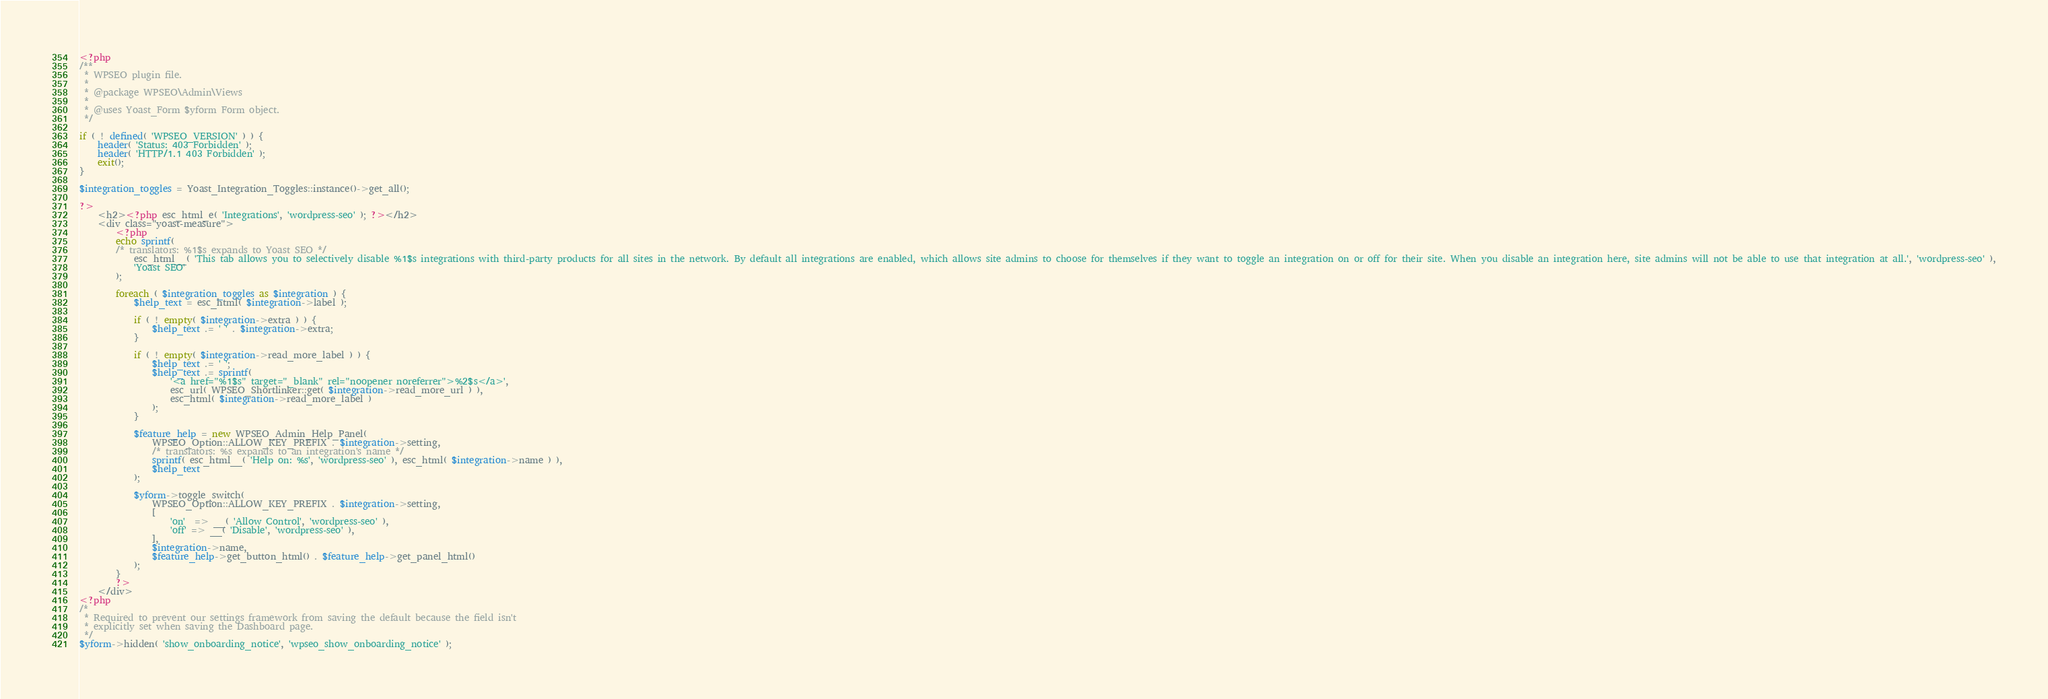<code> <loc_0><loc_0><loc_500><loc_500><_PHP_><?php
/**
 * WPSEO plugin file.
 *
 * @package WPSEO\Admin\Views
 *
 * @uses Yoast_Form $yform Form object.
 */

if ( ! defined( 'WPSEO_VERSION' ) ) {
	header( 'Status: 403 Forbidden' );
	header( 'HTTP/1.1 403 Forbidden' );
	exit();
}

$integration_toggles = Yoast_Integration_Toggles::instance()->get_all();

?>
	<h2><?php esc_html_e( 'Integrations', 'wordpress-seo' ); ?></h2>
	<div class="yoast-measure">
		<?php
		echo sprintf(
		/* translators: %1$s expands to Yoast SEO */
			esc_html__( 'This tab allows you to selectively disable %1$s integrations with third-party products for all sites in the network. By default all integrations are enabled, which allows site admins to choose for themselves if they want to toggle an integration on or off for their site. When you disable an integration here, site admins will not be able to use that integration at all.', 'wordpress-seo' ),
			'Yoast SEO'
		);

		foreach ( $integration_toggles as $integration ) {
			$help_text = esc_html( $integration->label );

			if ( ! empty( $integration->extra ) ) {
				$help_text .= ' ' . $integration->extra;
			}

			if ( ! empty( $integration->read_more_label ) ) {
				$help_text .= ' ';
				$help_text .= sprintf(
					'<a href="%1$s" target="_blank" rel="noopener noreferrer">%2$s</a>',
					esc_url( WPSEO_Shortlinker::get( $integration->read_more_url ) ),
					esc_html( $integration->read_more_label )
				);
			}

			$feature_help = new WPSEO_Admin_Help_Panel(
				WPSEO_Option::ALLOW_KEY_PREFIX . $integration->setting,
				/* translators: %s expands to an integration's name */
				sprintf( esc_html__( 'Help on: %s', 'wordpress-seo' ), esc_html( $integration->name ) ),
				$help_text
			);

			$yform->toggle_switch(
				WPSEO_Option::ALLOW_KEY_PREFIX . $integration->setting,
				[
					'on'  => __( 'Allow Control', 'wordpress-seo' ),
					'off' => __( 'Disable', 'wordpress-seo' ),
				],
				$integration->name,
				$feature_help->get_button_html() . $feature_help->get_panel_html()
			);
		}
		?>
	</div>
<?php
/*
 * Required to prevent our settings framework from saving the default because the field isn't
 * explicitly set when saving the Dashboard page.
 */
$yform->hidden( 'show_onboarding_notice', 'wpseo_show_onboarding_notice' );
</code> 